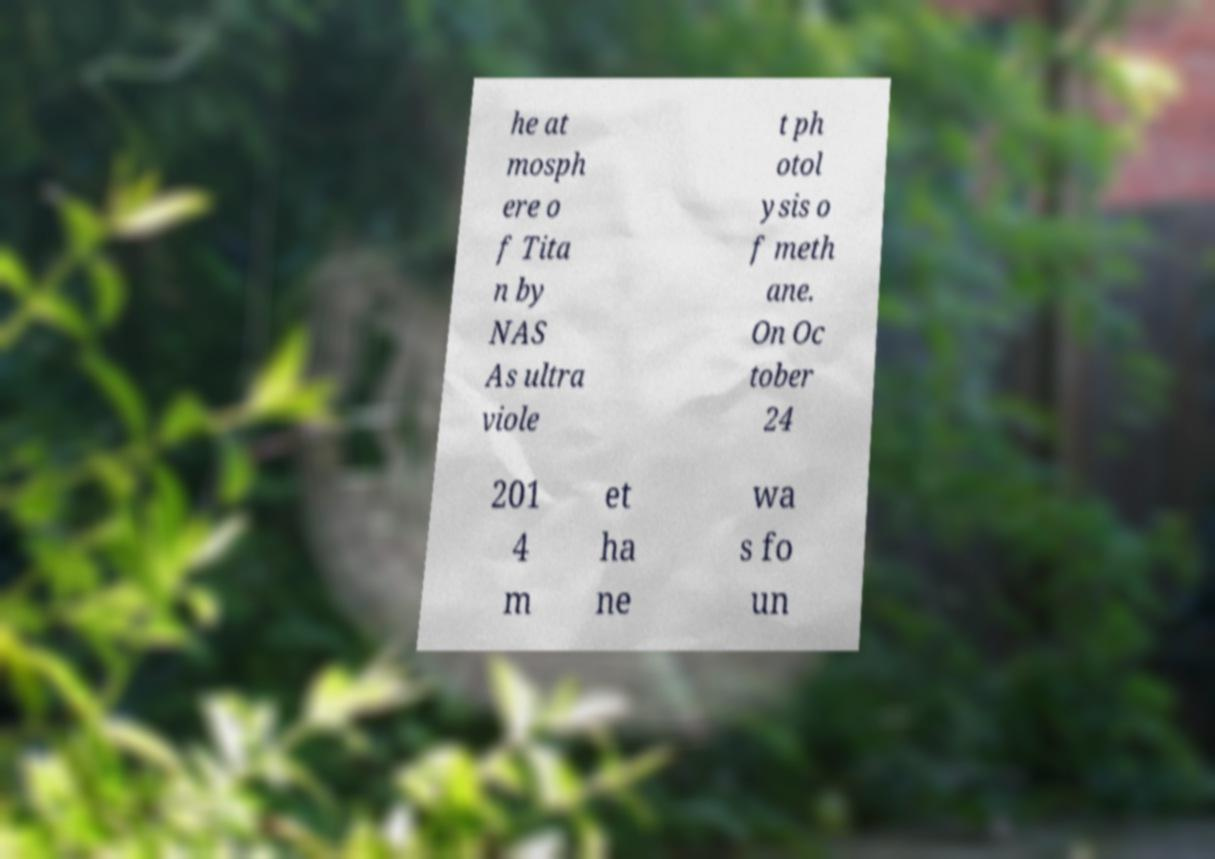Could you assist in decoding the text presented in this image and type it out clearly? he at mosph ere o f Tita n by NAS As ultra viole t ph otol ysis o f meth ane. On Oc tober 24 201 4 m et ha ne wa s fo un 